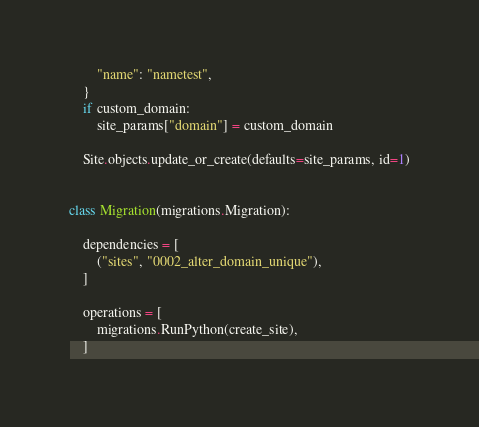Convert code to text. <code><loc_0><loc_0><loc_500><loc_500><_Python_>        "name": "nametest",
    }
    if custom_domain:
        site_params["domain"] = custom_domain

    Site.objects.update_or_create(defaults=site_params, id=1)


class Migration(migrations.Migration):

    dependencies = [
        ("sites", "0002_alter_domain_unique"),
    ]

    operations = [
        migrations.RunPython(create_site),
    ]
</code> 